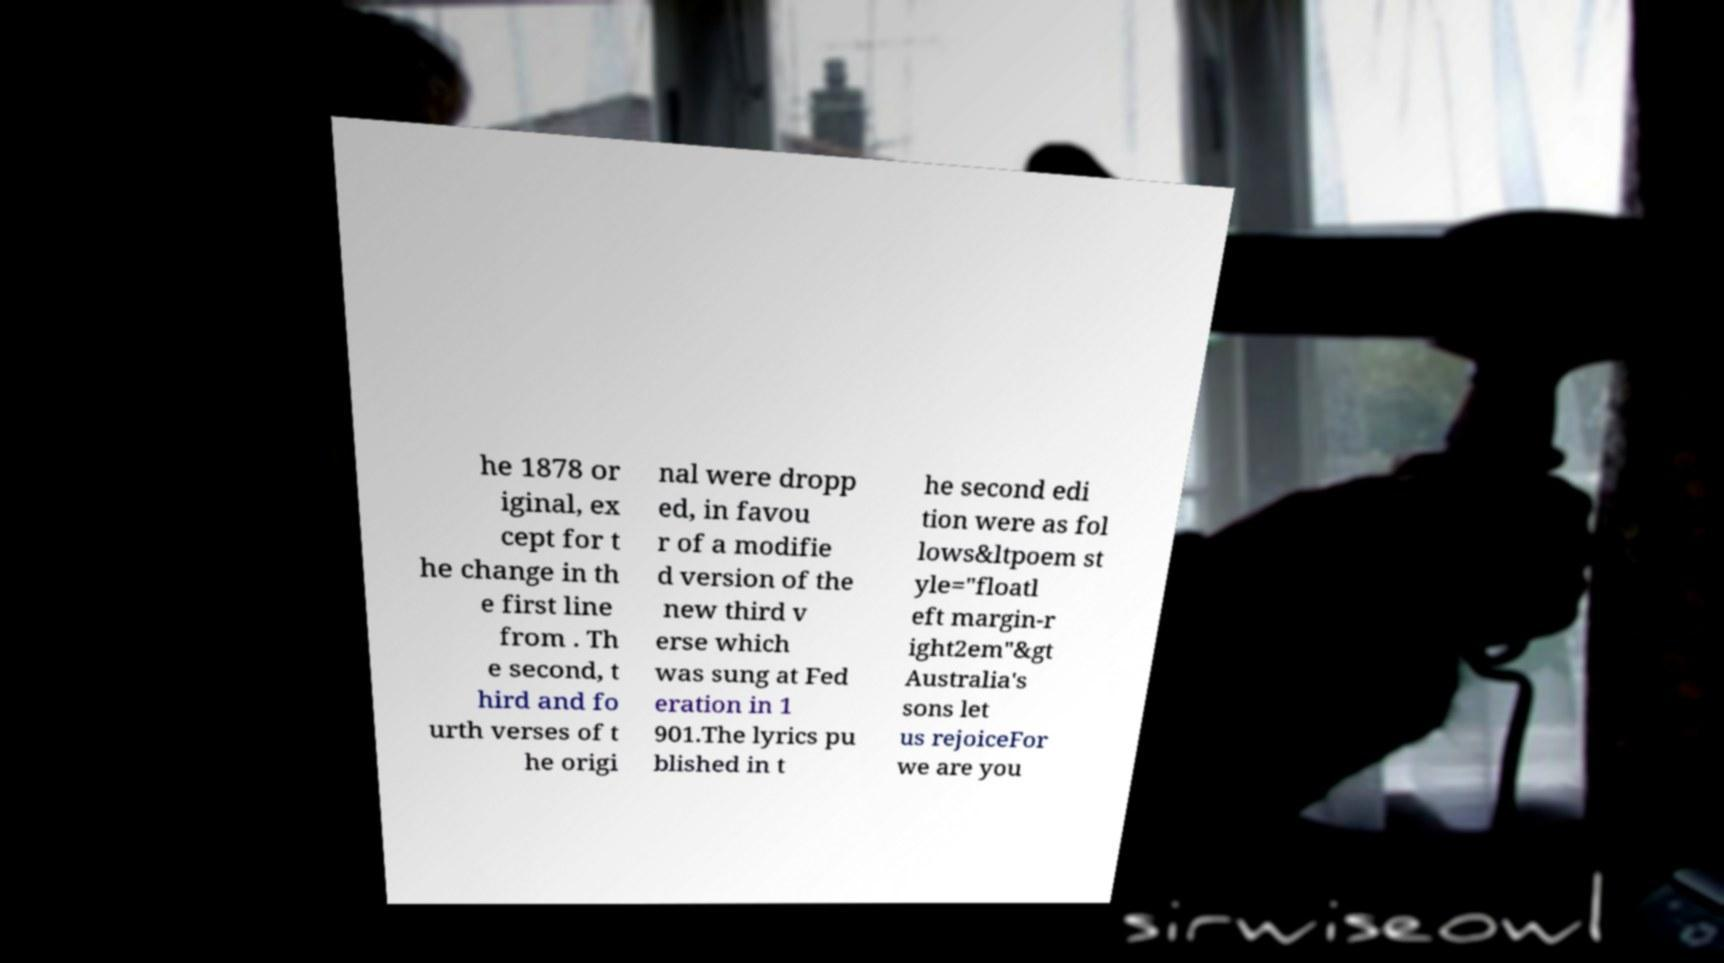I need the written content from this picture converted into text. Can you do that? he 1878 or iginal, ex cept for t he change in th e first line from . Th e second, t hird and fo urth verses of t he origi nal were dropp ed, in favou r of a modifie d version of the new third v erse which was sung at Fed eration in 1 901.The lyrics pu blished in t he second edi tion were as fol lows&ltpoem st yle="floatl eft margin-r ight2em"&gt Australia's sons let us rejoiceFor we are you 